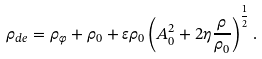<formula> <loc_0><loc_0><loc_500><loc_500>\rho _ { d e } = \rho _ { \varphi } + \rho _ { 0 } + \varepsilon \rho _ { 0 } \left ( A _ { 0 } ^ { 2 } + 2 \eta \frac { \rho } { \rho _ { 0 } } \right ) ^ { \frac { 1 } { 2 } } .</formula> 